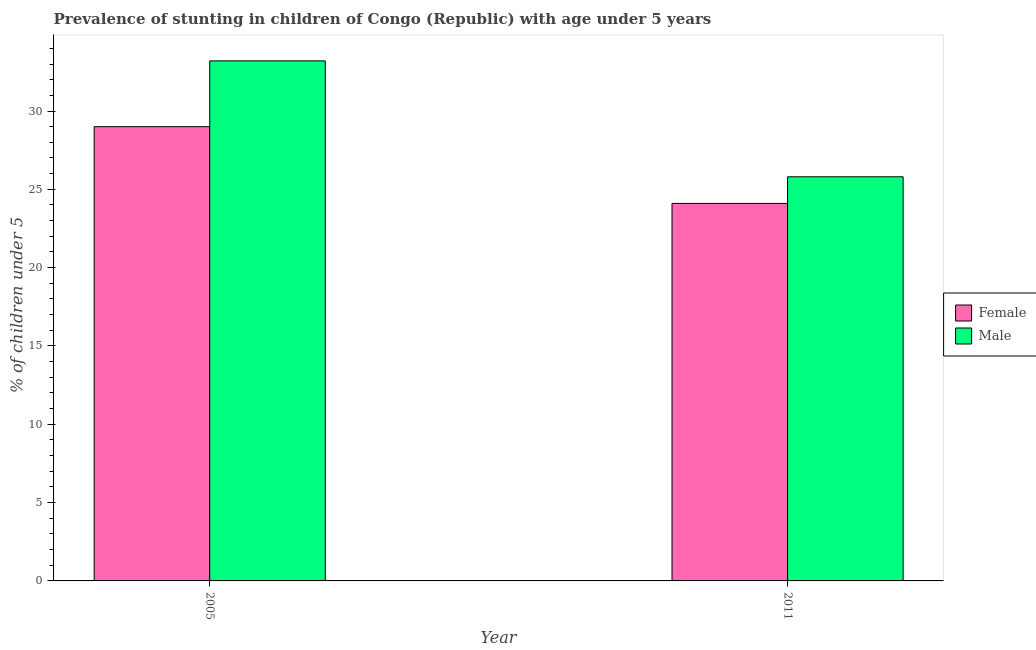How many different coloured bars are there?
Your response must be concise. 2. Are the number of bars per tick equal to the number of legend labels?
Your answer should be compact. Yes. How many bars are there on the 2nd tick from the right?
Give a very brief answer. 2. In how many cases, is the number of bars for a given year not equal to the number of legend labels?
Provide a succinct answer. 0. What is the percentage of stunted male children in 2005?
Make the answer very short. 33.2. Across all years, what is the minimum percentage of stunted male children?
Offer a terse response. 25.8. In which year was the percentage of stunted male children maximum?
Give a very brief answer. 2005. In which year was the percentage of stunted male children minimum?
Provide a short and direct response. 2011. What is the total percentage of stunted male children in the graph?
Make the answer very short. 59. What is the difference between the percentage of stunted female children in 2005 and that in 2011?
Provide a short and direct response. 4.9. What is the difference between the percentage of stunted female children in 2011 and the percentage of stunted male children in 2005?
Offer a terse response. -4.9. What is the average percentage of stunted male children per year?
Offer a very short reply. 29.5. What is the ratio of the percentage of stunted male children in 2005 to that in 2011?
Offer a terse response. 1.29. Is the percentage of stunted female children in 2005 less than that in 2011?
Offer a terse response. No. What does the 2nd bar from the left in 2011 represents?
Your answer should be compact. Male. What does the 2nd bar from the right in 2005 represents?
Provide a short and direct response. Female. How many bars are there?
Keep it short and to the point. 4. Are all the bars in the graph horizontal?
Offer a terse response. No. Does the graph contain any zero values?
Provide a short and direct response. No. Does the graph contain grids?
Your answer should be very brief. No. How many legend labels are there?
Give a very brief answer. 2. How are the legend labels stacked?
Your answer should be compact. Vertical. What is the title of the graph?
Your answer should be very brief. Prevalence of stunting in children of Congo (Republic) with age under 5 years. Does "Resident" appear as one of the legend labels in the graph?
Your answer should be very brief. No. What is the label or title of the Y-axis?
Provide a short and direct response.  % of children under 5. What is the  % of children under 5 in Male in 2005?
Offer a very short reply. 33.2. What is the  % of children under 5 of Female in 2011?
Your response must be concise. 24.1. What is the  % of children under 5 in Male in 2011?
Your response must be concise. 25.8. Across all years, what is the maximum  % of children under 5 in Female?
Ensure brevity in your answer.  29. Across all years, what is the maximum  % of children under 5 of Male?
Provide a short and direct response. 33.2. Across all years, what is the minimum  % of children under 5 in Female?
Provide a short and direct response. 24.1. Across all years, what is the minimum  % of children under 5 of Male?
Offer a very short reply. 25.8. What is the total  % of children under 5 in Female in the graph?
Offer a very short reply. 53.1. What is the total  % of children under 5 in Male in the graph?
Your answer should be compact. 59. What is the difference between the  % of children under 5 of Female in 2005 and that in 2011?
Keep it short and to the point. 4.9. What is the difference between the  % of children under 5 of Male in 2005 and that in 2011?
Provide a succinct answer. 7.4. What is the average  % of children under 5 in Female per year?
Your response must be concise. 26.55. What is the average  % of children under 5 in Male per year?
Your response must be concise. 29.5. In the year 2005, what is the difference between the  % of children under 5 in Female and  % of children under 5 in Male?
Give a very brief answer. -4.2. In the year 2011, what is the difference between the  % of children under 5 in Female and  % of children under 5 in Male?
Provide a succinct answer. -1.7. What is the ratio of the  % of children under 5 in Female in 2005 to that in 2011?
Your answer should be very brief. 1.2. What is the ratio of the  % of children under 5 in Male in 2005 to that in 2011?
Your answer should be compact. 1.29. What is the difference between the highest and the second highest  % of children under 5 in Female?
Provide a succinct answer. 4.9. What is the difference between the highest and the lowest  % of children under 5 in Male?
Your response must be concise. 7.4. 